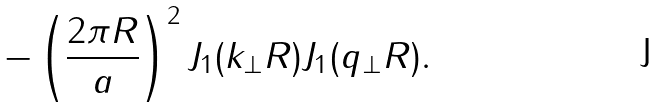Convert formula to latex. <formula><loc_0><loc_0><loc_500><loc_500>- \left ( \frac { 2 \pi R } { a } \right ) ^ { 2 } J _ { 1 } ( k _ { \bot } R ) J _ { 1 } ( q _ { \bot } R ) .</formula> 